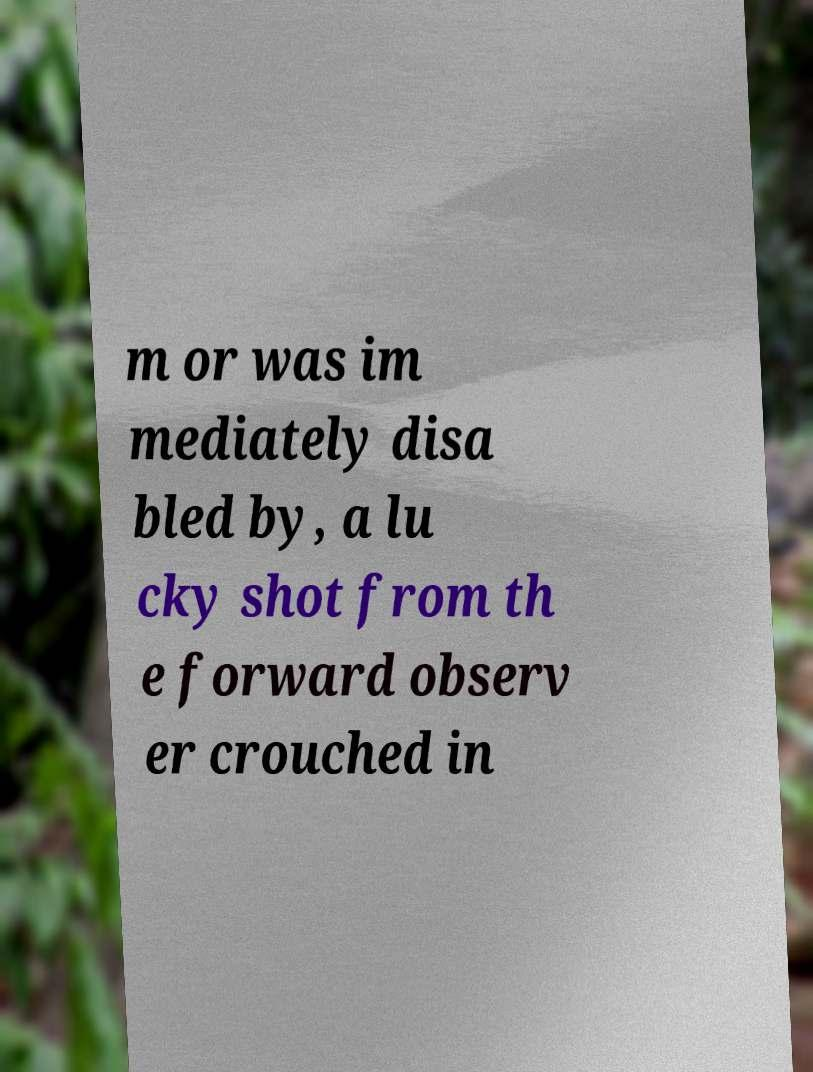Could you assist in decoding the text presented in this image and type it out clearly? m or was im mediately disa bled by, a lu cky shot from th e forward observ er crouched in 